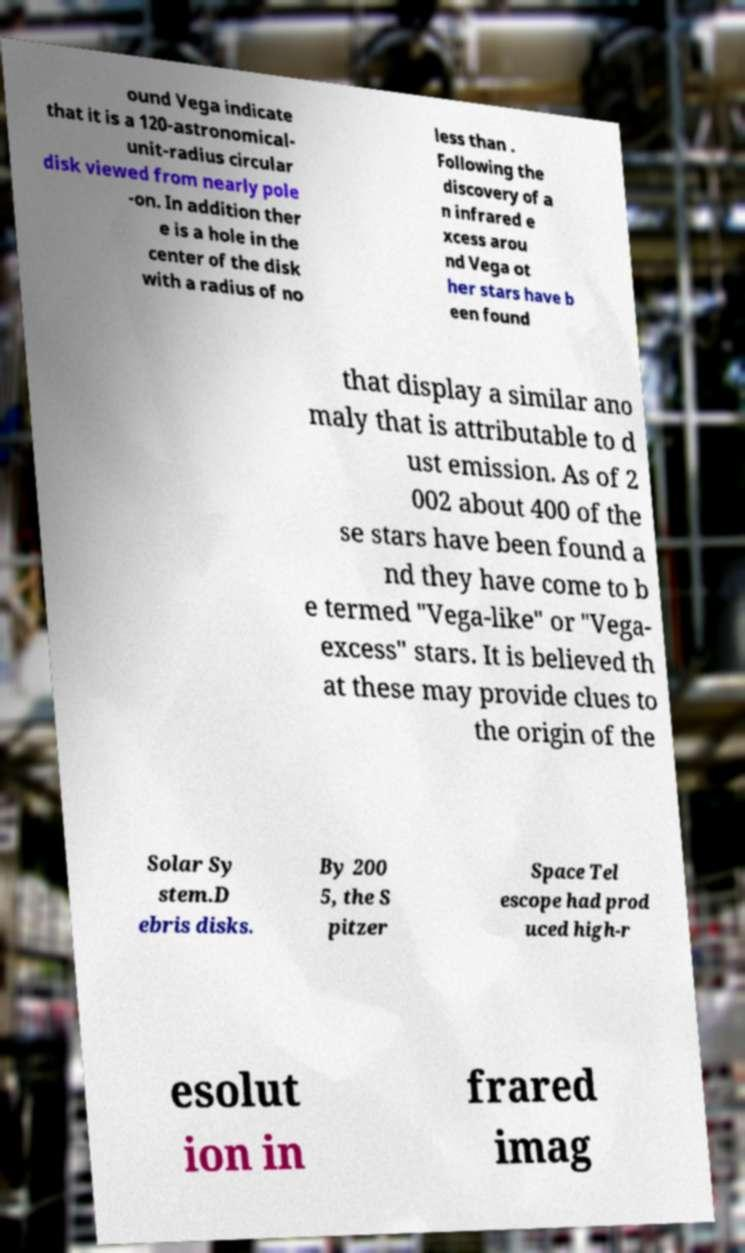Could you assist in decoding the text presented in this image and type it out clearly? ound Vega indicate that it is a 120-astronomical- unit-radius circular disk viewed from nearly pole -on. In addition ther e is a hole in the center of the disk with a radius of no less than . Following the discovery of a n infrared e xcess arou nd Vega ot her stars have b een found that display a similar ano maly that is attributable to d ust emission. As of 2 002 about 400 of the se stars have been found a nd they have come to b e termed "Vega-like" or "Vega- excess" stars. It is believed th at these may provide clues to the origin of the Solar Sy stem.D ebris disks. By 200 5, the S pitzer Space Tel escope had prod uced high-r esolut ion in frared imag 